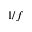<formula> <loc_0><loc_0><loc_500><loc_500>1 / f</formula> 